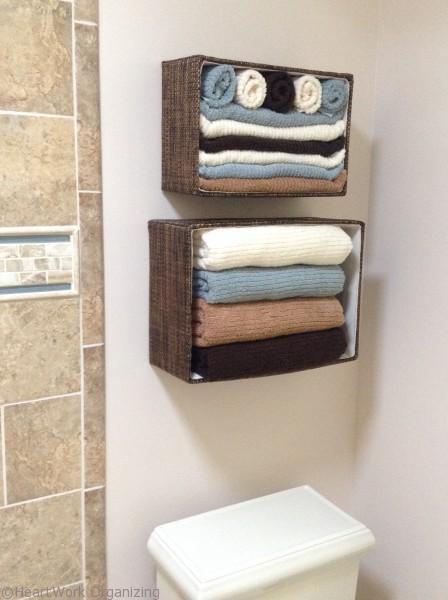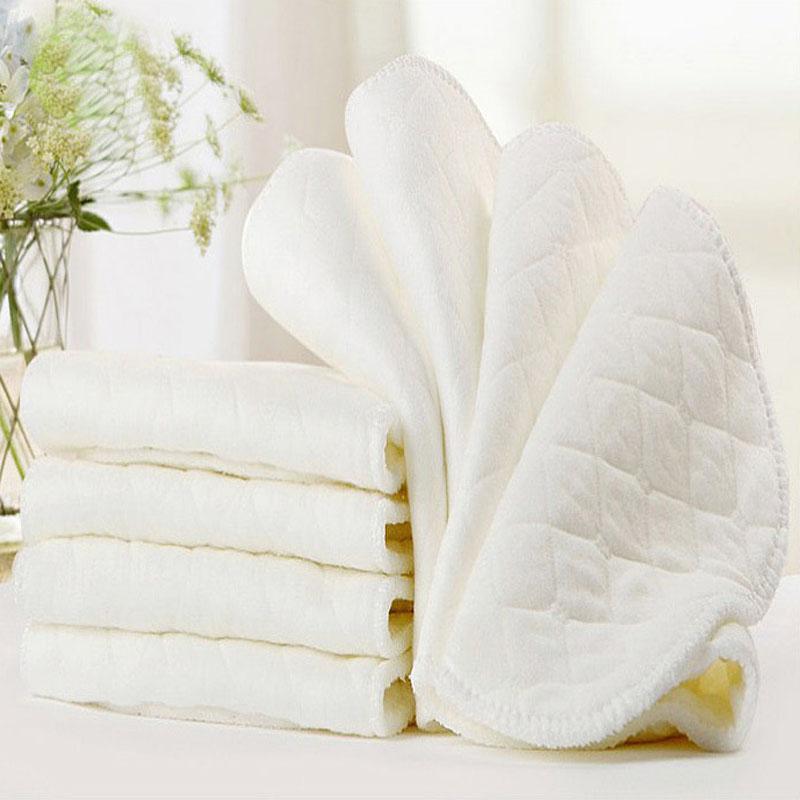The first image is the image on the left, the second image is the image on the right. Considering the images on both sides, is "There is at least part of a toilet shown." valid? Answer yes or no. Yes. 